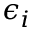Convert formula to latex. <formula><loc_0><loc_0><loc_500><loc_500>\epsilon _ { i }</formula> 